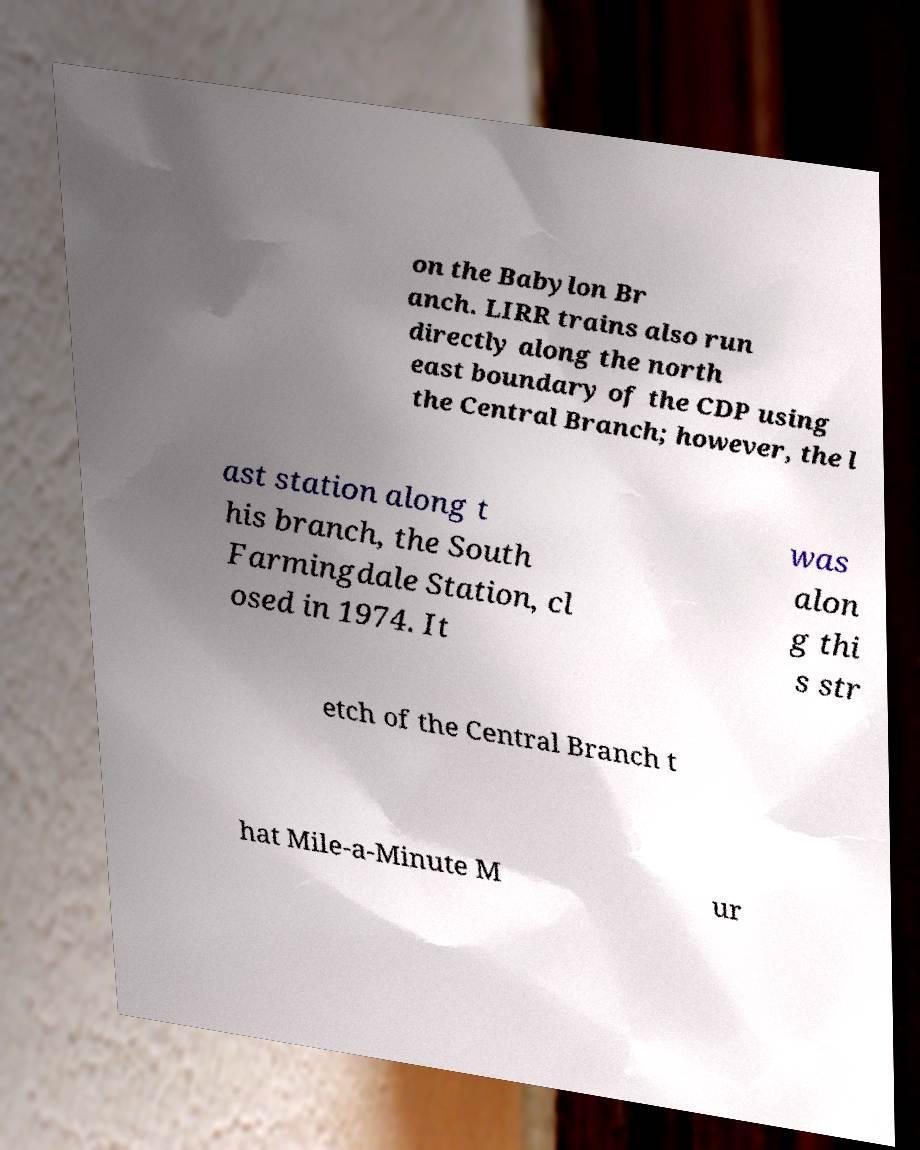Please identify and transcribe the text found in this image. on the Babylon Br anch. LIRR trains also run directly along the north east boundary of the CDP using the Central Branch; however, the l ast station along t his branch, the South Farmingdale Station, cl osed in 1974. It was alon g thi s str etch of the Central Branch t hat Mile-a-Minute M ur 